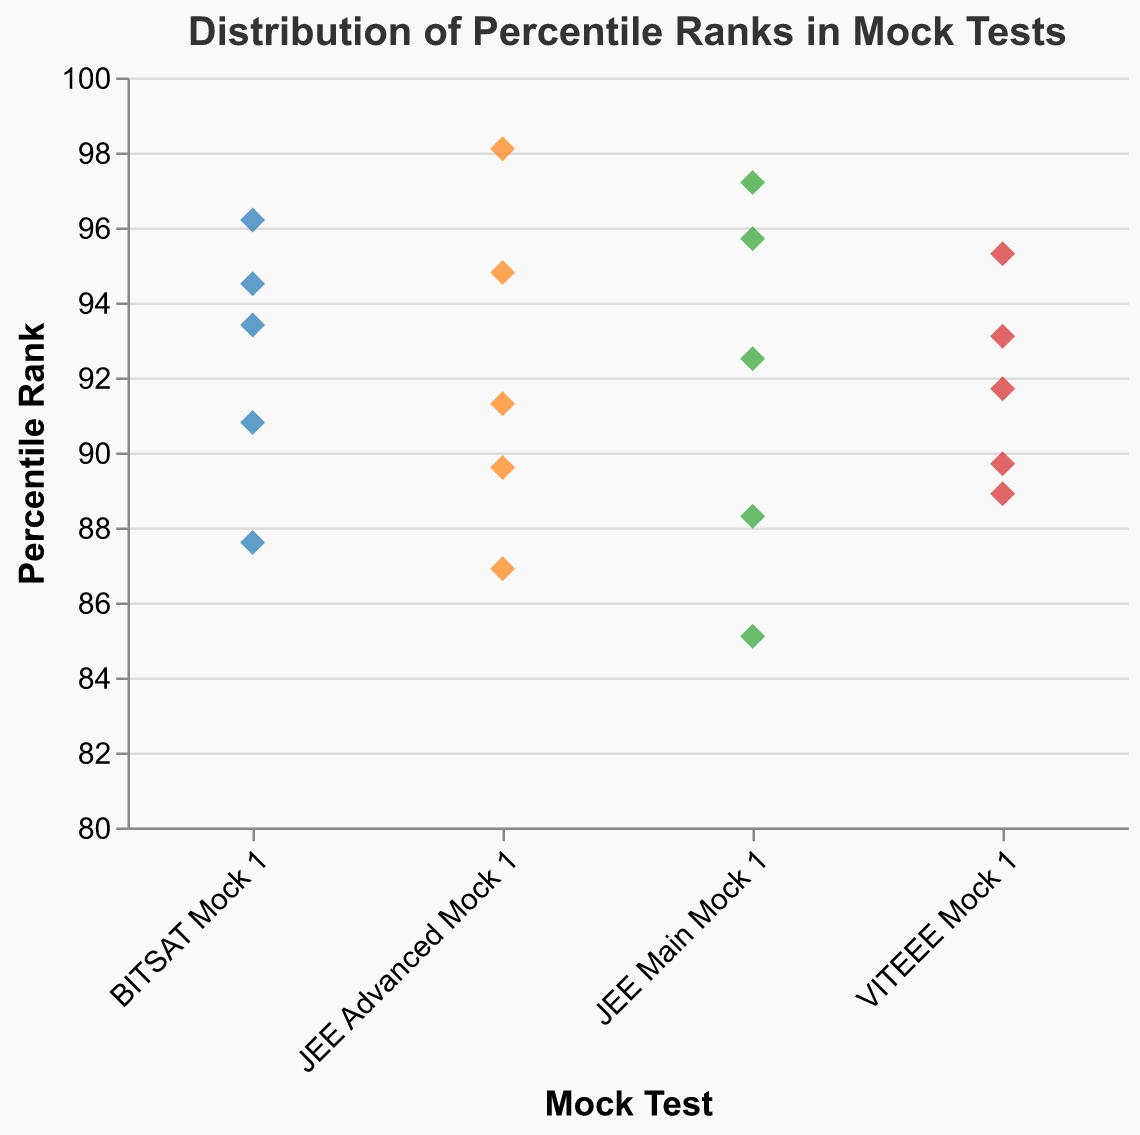What is the title of the plot? The title of the plot is shown at the top of the figure. It reads "Distribution of Percentile Ranks in Mock Tests".
Answer: Distribution of Percentile Ranks in Mock Tests Which mock test has the data point with the highest percentile rank? We need to look at the highest percentile rank on the y-axis and match it to the corresponding mock test on the x-axis. The highest percentile rank is 98.1, achieved in "JEE Advanced Mock 1".
Answer: JEE Advanced Mock 1 How many data points are plotted for the "VITEEE Mock 1"? Observe the number of points aligned with "VITEEE Mock 1" on the x-axis. There are 5 points plotted for "VITEEE Mock 1".
Answer: 5 What is the average percentile rank of students in "BITSAT Mock 1"? Sum all the percentile values for "BITSAT Mock 1" and then divide by the number of data points. The percentiles are 93.4, 87.6, 96.2, 90.8, and 94.5. So, (93.4 + 87.6 + 96.2 + 90.8 + 94.5) / 5 = 462.5 / 5 = 92.5.
Answer: 92.5 Which mock test has the widest range of percentile ranks? To determine the widest range, we need to find the difference between the maximum and minimum percentile values for each mock test. The ranges are: "JEE Main Mock 1" (97.2 - 85.1 = 12.1), "JEE Advanced Mock 1" (98.1 - 86.9 = 11.2), "BITSAT Mock 1" (96.2 - 87.6 = 8.6), and "VITEEE Mock 1" (95.3 - 88.9 = 6.4). The widest range is for "JEE Main Mock 1" with 12.1.
Answer: JEE Main Mock 1 Which mock test has the least variation in student performance? To determine the least variation, we need to consider the range or spread of data points. "VITEEE Mock 1" has the least variation with a range of 95.3 - 88.9 = 6.4.
Answer: VITEEE Mock 1 What is the percentile rank of the lowest data point in "JEE Main Mock 1"? Identify the lowest point for "JEE Main Mock 1" by observing the values on the y-axis. The lowest percentile rank in "JEE Main Mock 1" is 85.1.
Answer: 85.1 